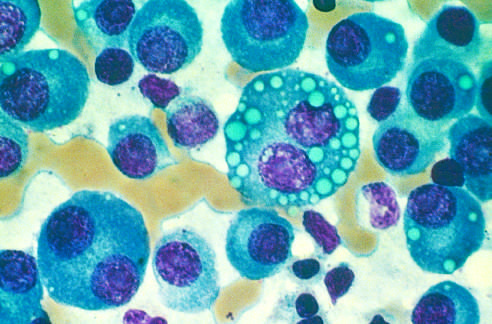what are largely replaced by plasma cells, including atypical forms with multiple nuclei, prominent nucleoli, and cyto-plasmic droplets containing immunoglobulin?
Answer the question using a single word or phrase. Normal marrow cells 